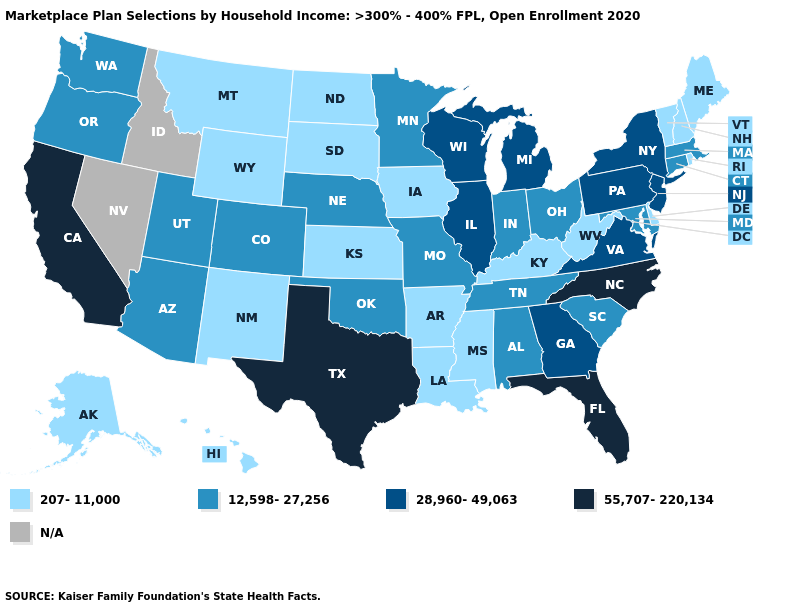Among the states that border South Carolina , which have the lowest value?
Answer briefly. Georgia. Does Georgia have the highest value in the South?
Answer briefly. No. Among the states that border Illinois , does Wisconsin have the highest value?
Concise answer only. Yes. What is the value of Arizona?
Quick response, please. 12,598-27,256. Does Nebraska have the lowest value in the USA?
Short answer required. No. Does Massachusetts have the lowest value in the Northeast?
Be succinct. No. Among the states that border Wyoming , does Nebraska have the lowest value?
Give a very brief answer. No. Does North Dakota have the highest value in the USA?
Short answer required. No. What is the highest value in states that border North Dakota?
Keep it brief. 12,598-27,256. Name the states that have a value in the range N/A?
Answer briefly. Idaho, Nevada. Does Iowa have the lowest value in the MidWest?
Quick response, please. Yes. What is the value of Nebraska?
Concise answer only. 12,598-27,256. How many symbols are there in the legend?
Answer briefly. 5. Which states have the lowest value in the MidWest?
Write a very short answer. Iowa, Kansas, North Dakota, South Dakota. 